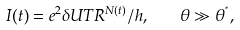<formula> <loc_0><loc_0><loc_500><loc_500>I ( t ) = e ^ { 2 } \delta U T R ^ { N ( t ) } / h , \quad \theta \gg \theta ^ { ^ { * } } ,</formula> 